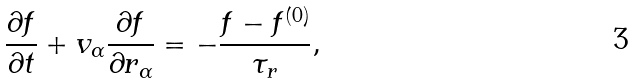Convert formula to latex. <formula><loc_0><loc_0><loc_500><loc_500>\frac { \partial f } { \partial t } + v _ { \alpha } \frac { \partial f } { \partial r _ { \alpha } } = - \frac { f - f ^ { ( 0 ) } } { \tau _ { r } } ,</formula> 